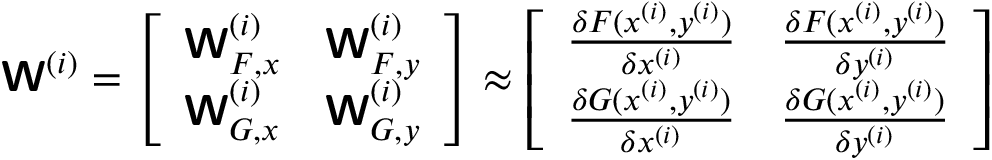<formula> <loc_0><loc_0><loc_500><loc_500>W ^ { ( i ) } = \left [ \begin{array} { l l } { W _ { F , x } ^ { ( i ) } } & { W _ { F , y } ^ { ( i ) } } \\ { W _ { G , x } ^ { ( i ) } } & { W _ { G , y } ^ { ( i ) } } \end{array} \right ] \approx \left [ \begin{array} { l l } { \frac { \delta F ( x ^ { ( i ) } , y ^ { ( i ) } ) } { \delta x ^ { ( i ) } } } & { \frac { \delta F ( x ^ { ( i ) } , y ^ { ( i ) } ) } { \delta y ^ { ( i ) } } } \\ { \frac { \delta G ( x ^ { ( i ) } , y ^ { ( i ) } ) } { \delta x ^ { ( i ) } } } & { \frac { \delta G ( x ^ { ( i ) } , y ^ { ( i ) } ) } { \delta y ^ { ( i ) } } } \end{array} \right ]</formula> 